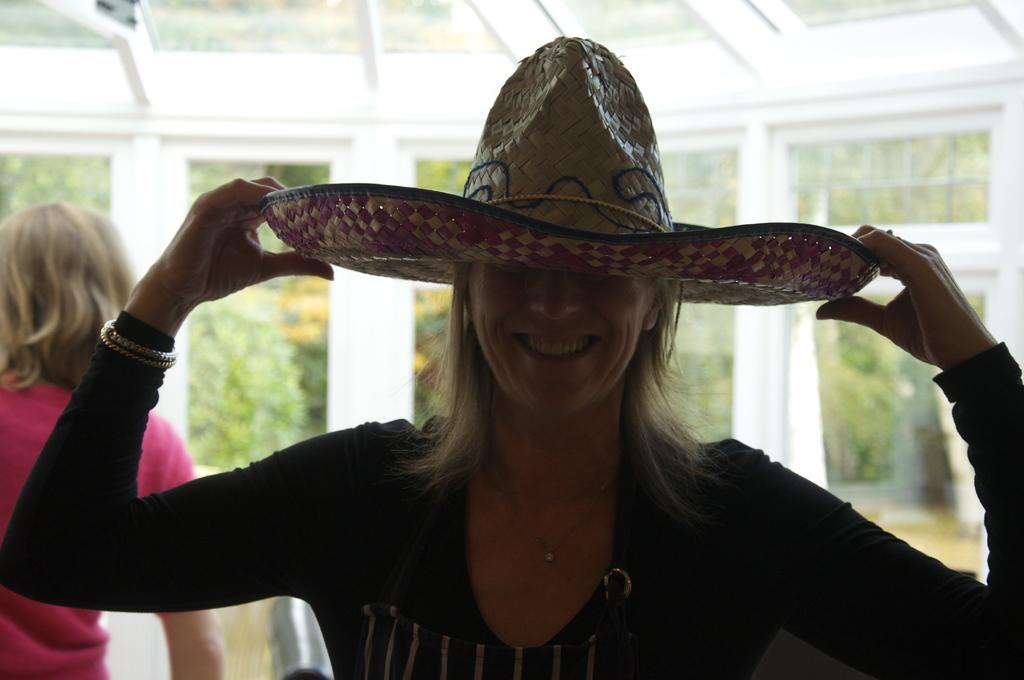What is the main subject of the image? There is a woman in the image. What is the woman holding? The woman is holding a hat. Can you describe the woman behind the first woman? There is another woman behind the first woman. What type of architectural feature is present in the image? There are glass windows in the image. What can be seen through the glass windows? Trees are visible behind the glass windows. What type of party is being held in the image? There is no indication of a party in the image. How much waste is visible in the image? There is no waste visible in the image. 